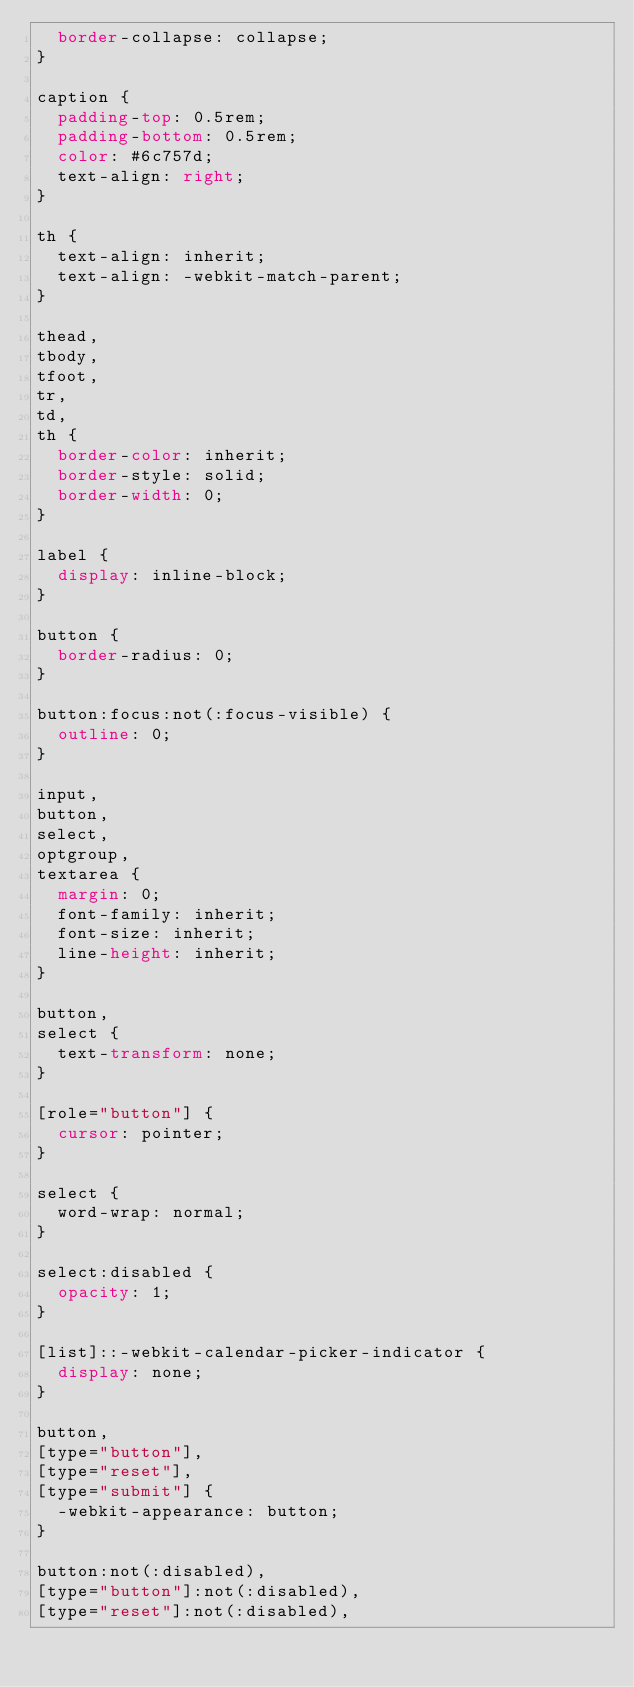Convert code to text. <code><loc_0><loc_0><loc_500><loc_500><_CSS_>  border-collapse: collapse;
}

caption {
  padding-top: 0.5rem;
  padding-bottom: 0.5rem;
  color: #6c757d;
  text-align: right;
}

th {
  text-align: inherit;
  text-align: -webkit-match-parent;
}

thead,
tbody,
tfoot,
tr,
td,
th {
  border-color: inherit;
  border-style: solid;
  border-width: 0;
}

label {
  display: inline-block;
}

button {
  border-radius: 0;
}

button:focus:not(:focus-visible) {
  outline: 0;
}

input,
button,
select,
optgroup,
textarea {
  margin: 0;
  font-family: inherit;
  font-size: inherit;
  line-height: inherit;
}

button,
select {
  text-transform: none;
}

[role="button"] {
  cursor: pointer;
}

select {
  word-wrap: normal;
}

select:disabled {
  opacity: 1;
}

[list]::-webkit-calendar-picker-indicator {
  display: none;
}

button,
[type="button"],
[type="reset"],
[type="submit"] {
  -webkit-appearance: button;
}

button:not(:disabled),
[type="button"]:not(:disabled),
[type="reset"]:not(:disabled),</code> 